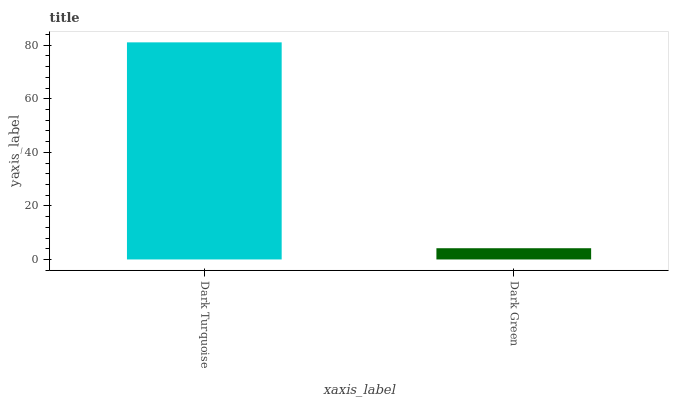Is Dark Green the maximum?
Answer yes or no. No. Is Dark Turquoise greater than Dark Green?
Answer yes or no. Yes. Is Dark Green less than Dark Turquoise?
Answer yes or no. Yes. Is Dark Green greater than Dark Turquoise?
Answer yes or no. No. Is Dark Turquoise less than Dark Green?
Answer yes or no. No. Is Dark Turquoise the high median?
Answer yes or no. Yes. Is Dark Green the low median?
Answer yes or no. Yes. Is Dark Green the high median?
Answer yes or no. No. Is Dark Turquoise the low median?
Answer yes or no. No. 